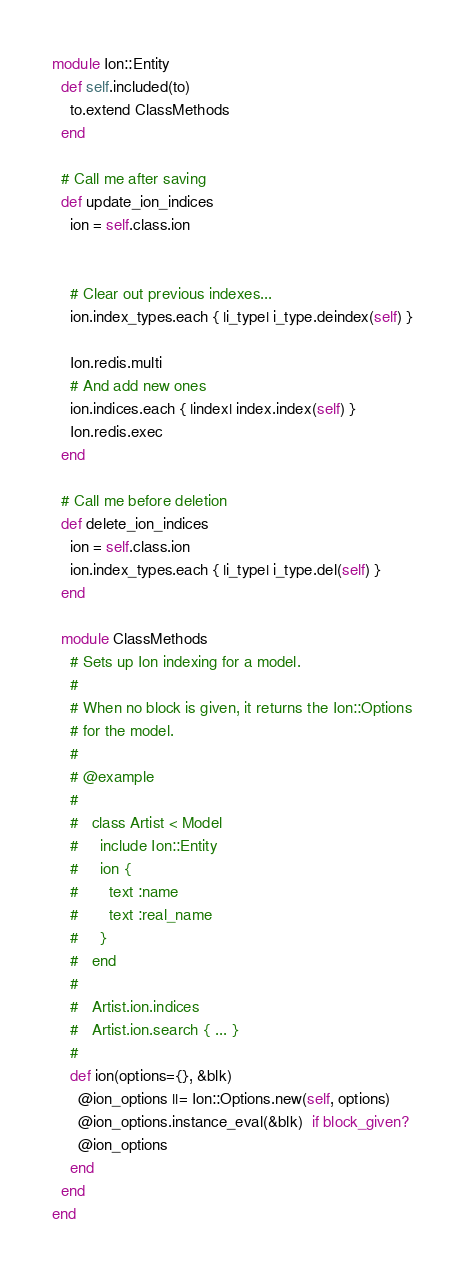Convert code to text. <code><loc_0><loc_0><loc_500><loc_500><_Ruby_>module Ion::Entity
  def self.included(to)
    to.extend ClassMethods
  end

  # Call me after saving
  def update_ion_indices
    ion = self.class.ion


    # Clear out previous indexes...
    ion.index_types.each { |i_type| i_type.deindex(self) }

    Ion.redis.multi
    # And add new ones
    ion.indices.each { |index| index.index(self) }
    Ion.redis.exec
  end

  # Call me before deletion
  def delete_ion_indices
    ion = self.class.ion
    ion.index_types.each { |i_type| i_type.del(self) }
  end

  module ClassMethods
    # Sets up Ion indexing for a model.
    #
    # When no block is given, it returns the Ion::Options
    # for the model.
    #
    # @example
    #
    #   class Artist < Model
    #     include Ion::Entity
    #     ion {
    #       text :name
    #       text :real_name
    #     }
    #   end
    #
    #   Artist.ion.indices
    #   Artist.ion.search { ... }
    #
    def ion(options={}, &blk)
      @ion_options ||= Ion::Options.new(self, options)
      @ion_options.instance_eval(&blk)  if block_given?
      @ion_options
    end
  end
end
</code> 